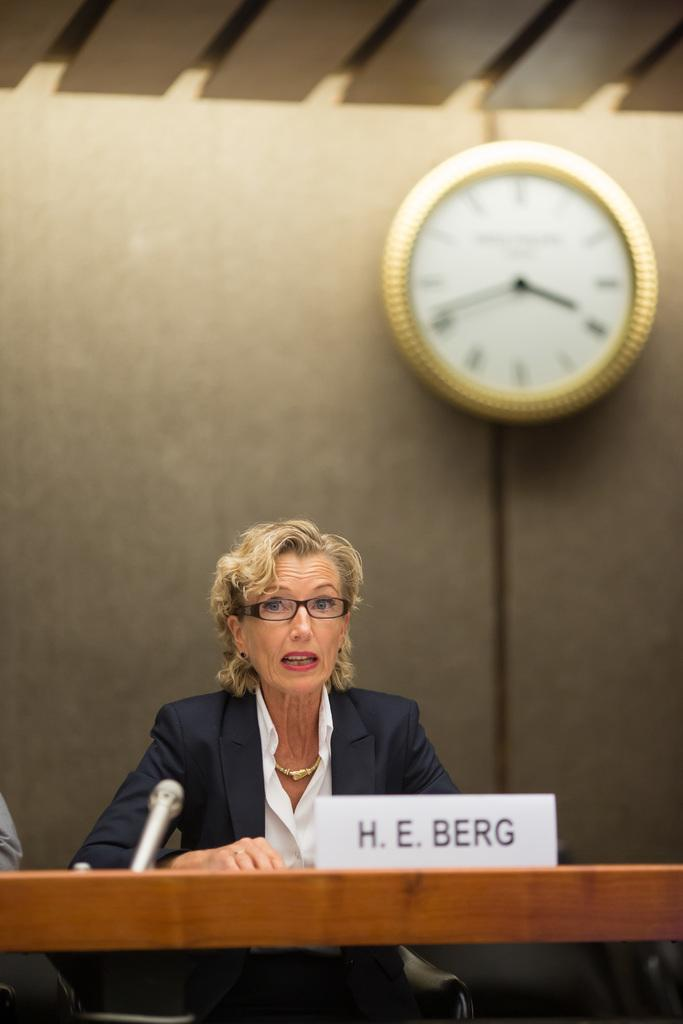<image>
Offer a succinct explanation of the picture presented. H.E. Berg is seated at a table with a microphone. 